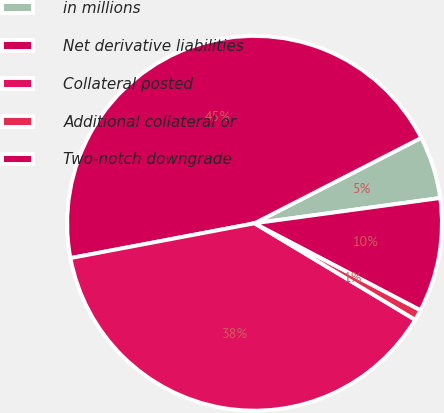<chart> <loc_0><loc_0><loc_500><loc_500><pie_chart><fcel>in millions<fcel>Net derivative liabilities<fcel>Collateral posted<fcel>Additional collateral or<fcel>Two-notch downgrade<nl><fcel>5.38%<fcel>45.43%<fcel>38.41%<fcel>0.93%<fcel>9.83%<nl></chart> 